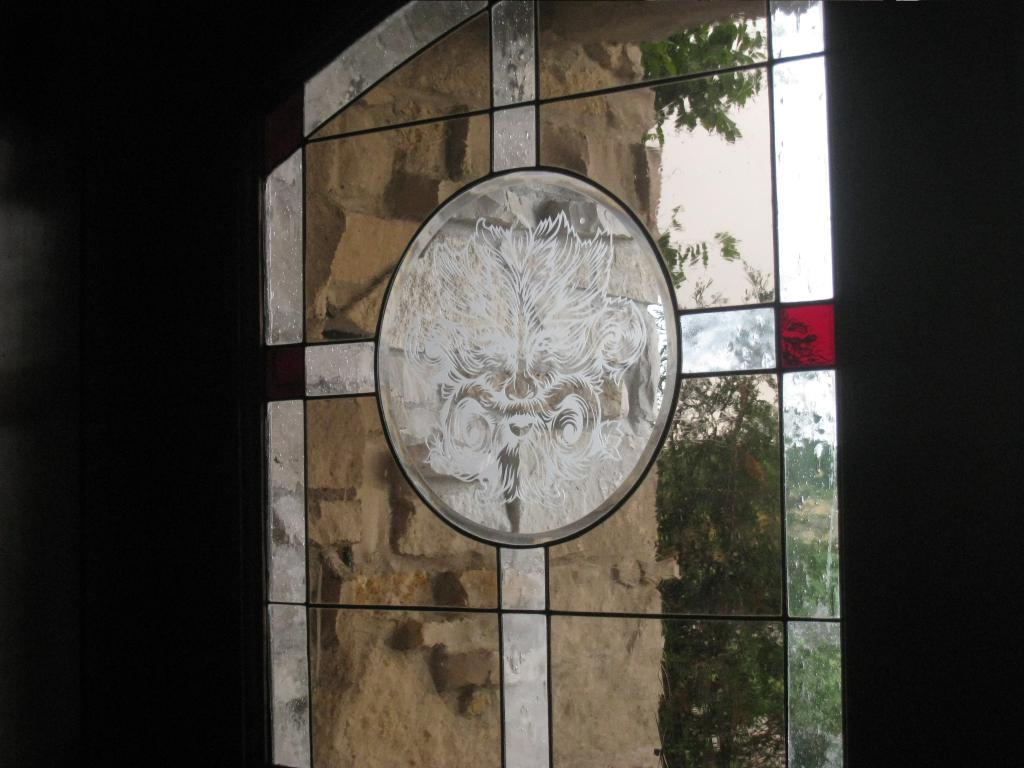What type of object is in the image that has a design on it? There is a designed glass in the image. What can be seen through the glass? A wall and trees are visible through the glass. What is the lighting condition on the left side of the image? The left side of the image is dark. What is the lighting condition on the right side of the image? The right side of the image is dark. How many cannons are placed on the beds in the image? There are no cannons or beds present in the image. What is the chin's position in the image? There is no chin present in the image. 